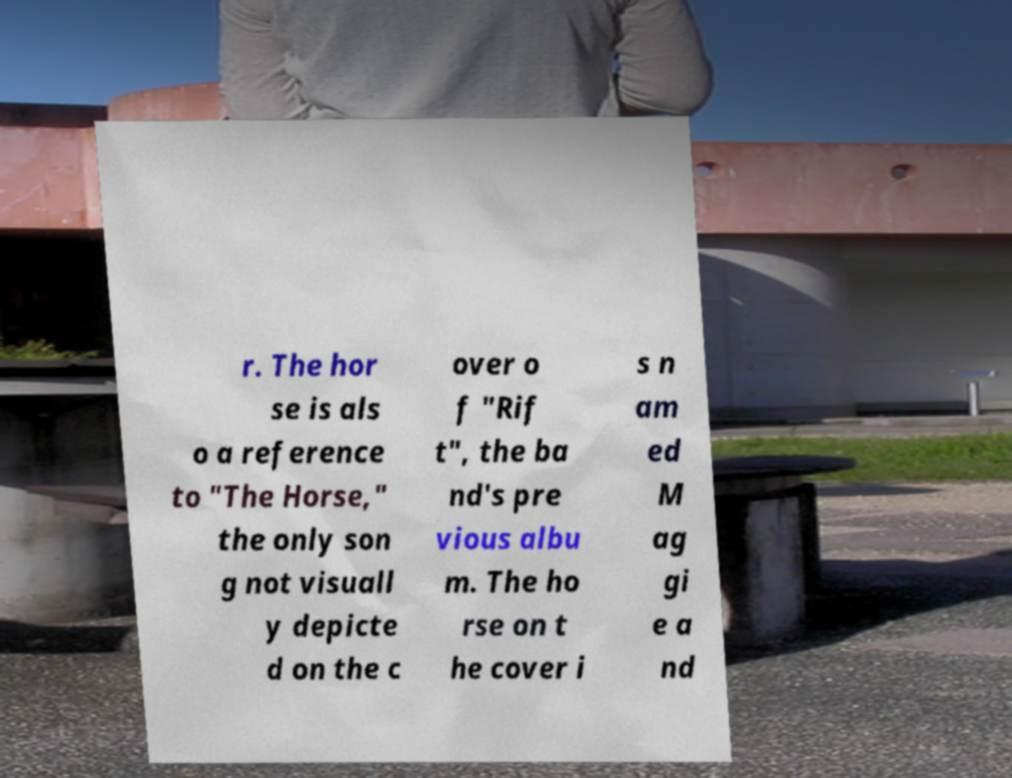There's text embedded in this image that I need extracted. Can you transcribe it verbatim? r. The hor se is als o a reference to "The Horse," the only son g not visuall y depicte d on the c over o f "Rif t", the ba nd's pre vious albu m. The ho rse on t he cover i s n am ed M ag gi e a nd 